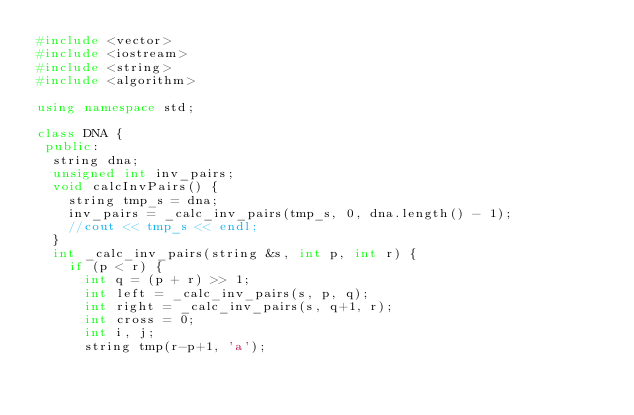Convert code to text. <code><loc_0><loc_0><loc_500><loc_500><_C++_>#include <vector>
#include <iostream>
#include <string>
#include <algorithm>

using namespace std;

class DNA {
 public:
  string dna;
  unsigned int inv_pairs;
  void calcInvPairs() {
    string tmp_s = dna;
    inv_pairs = _calc_inv_pairs(tmp_s, 0, dna.length() - 1);
    //cout << tmp_s << endl;
  }
  int _calc_inv_pairs(string &s, int p, int r) {
    if (p < r) {
      int q = (p + r) >> 1;
      int left = _calc_inv_pairs(s, p, q);
      int right = _calc_inv_pairs(s, q+1, r);
      int cross = 0;
      int i, j;
      string tmp(r-p+1, 'a');</code> 